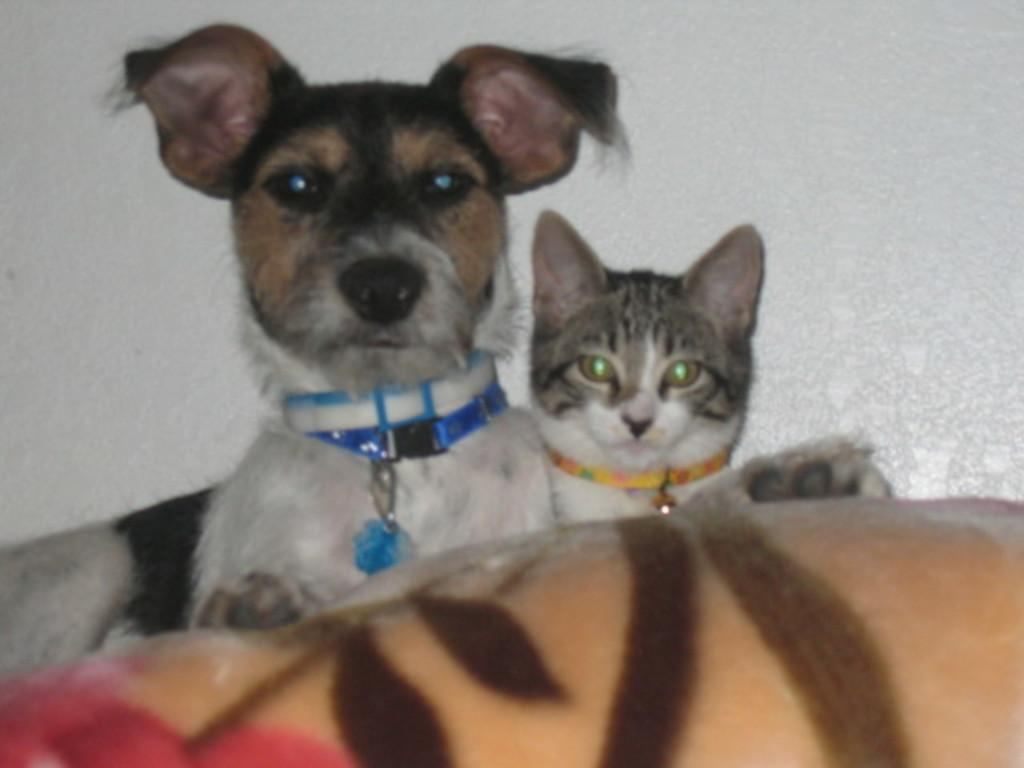What animals can be seen in the image? There is a dog and a cat in the image. What is the background of the image? There is a white wall in the background of the image. Can you describe the foreground of the image? There is an unspecified object or element in the foreground of the image. What route does the thumb take to reach the stranger in the image? There is no thumb or stranger present in the image. 